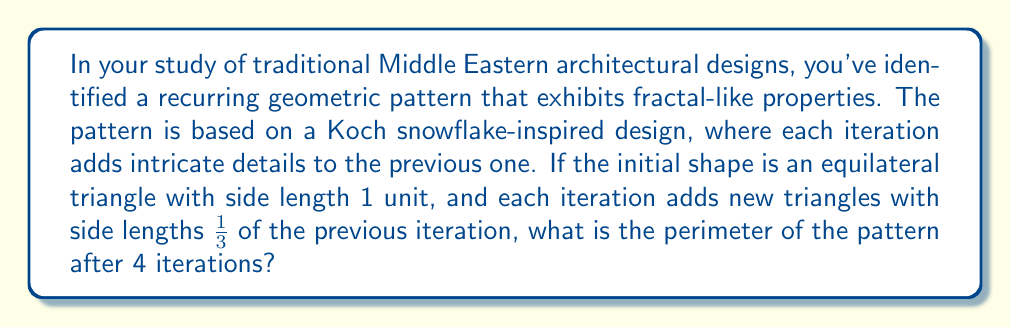Can you solve this math problem? Let's approach this step-by-step:

1) The initial shape is an equilateral triangle with side length 1 unit.
   Initial perimeter = $3 \times 1 = 3$ units

2) In each iteration, we replace the middle third of each side with two sides of a smaller equilateral triangle.

3) Let's calculate the number of sides and their length for each iteration:

   Iteration 0: 3 sides of length 1
   Iteration 1: $3 \times 4 = 12$ sides of length $\frac{1}{3}$
   Iteration 2: $12 \times 4 = 48$ sides of length $\frac{1}{9}$
   Iteration 3: $48 \times 4 = 192$ sides of length $\frac{1}{27}$
   Iteration 4: $192 \times 4 = 768$ sides of length $\frac{1}{81}$

4) The perimeter after 4 iterations is:

   $$ P_4 = 768 \times \frac{1}{81} = \frac{768}{81} = \frac{256}{27} $$

5) We can verify this using the general formula for the Koch snowflake perimeter:

   $$ P_n = 3 \times (\frac{4}{3})^n $$

   For $n = 4$:
   $$ P_4 = 3 \times (\frac{4}{3})^4 = 3 \times \frac{256}{81} = \frac{768}{81} = \frac{256}{27} $$

This confirms our step-by-step calculation.
Answer: $\frac{256}{27}$ units 